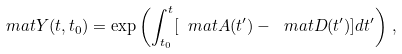<formula> <loc_0><loc_0><loc_500><loc_500>\ m a t Y ( t , t _ { 0 } ) = \exp \left ( \int _ { t _ { 0 } } ^ { t } [ \ m a t A ( t ^ { \prime } ) - \ m a t D ( t ^ { \prime } ) ] d t ^ { \prime } \right ) \, ,</formula> 